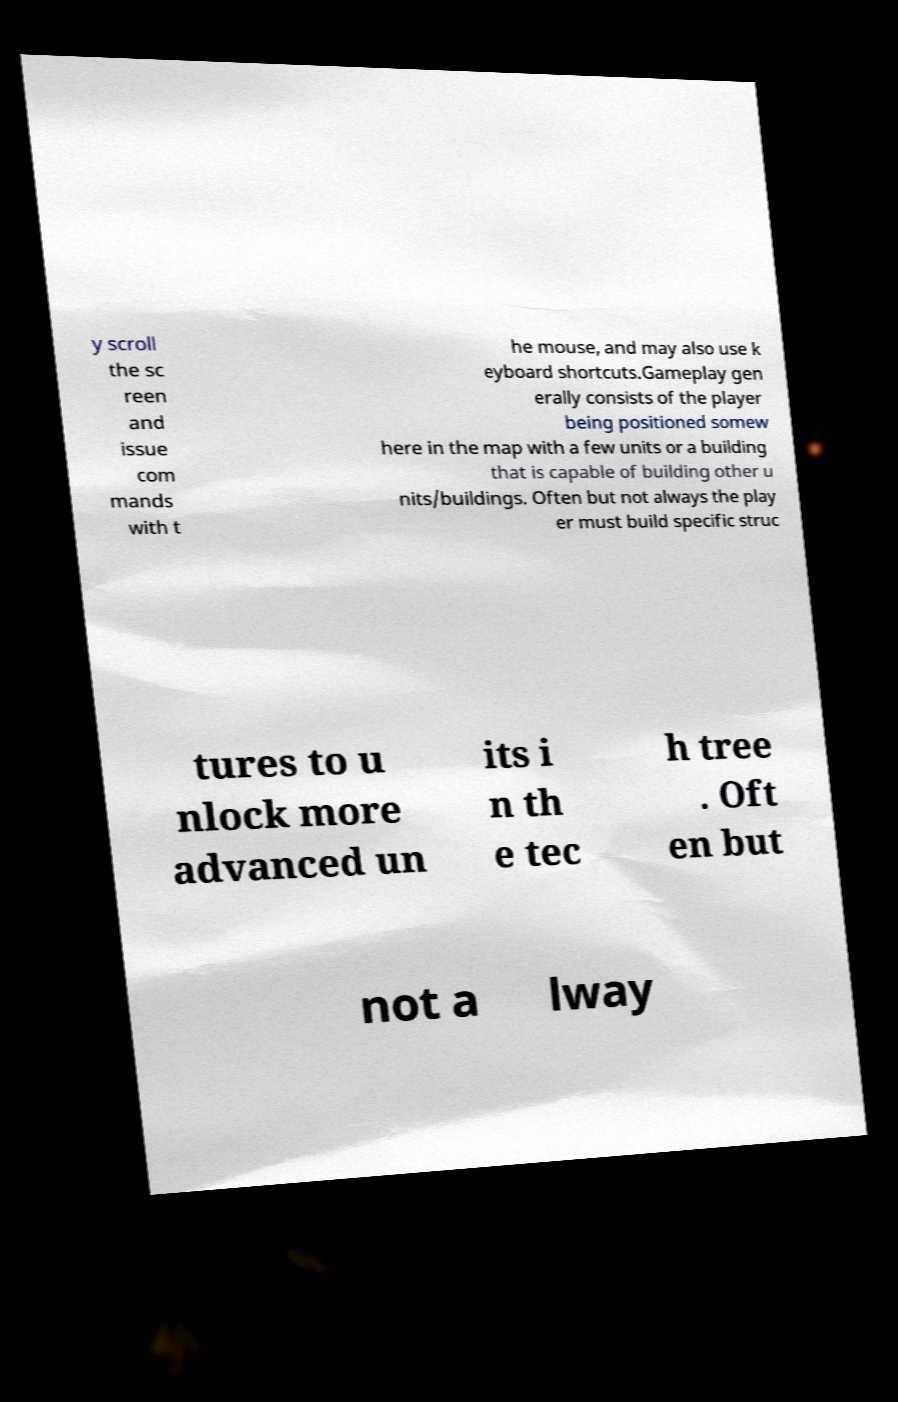Could you assist in decoding the text presented in this image and type it out clearly? y scroll the sc reen and issue com mands with t he mouse, and may also use k eyboard shortcuts.Gameplay gen erally consists of the player being positioned somew here in the map with a few units or a building that is capable of building other u nits/buildings. Often but not always the play er must build specific struc tures to u nlock more advanced un its i n th e tec h tree . Oft en but not a lway 